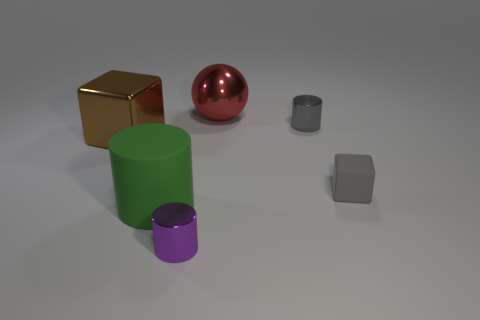Are the objects presented here made of the same material? The objects in the image appear to have different materials, as indicated by their varying colors and surface reflections. The metallic sheen on the red sphere and the golden cube suggests a reflective material, while the others have matte finishes. 